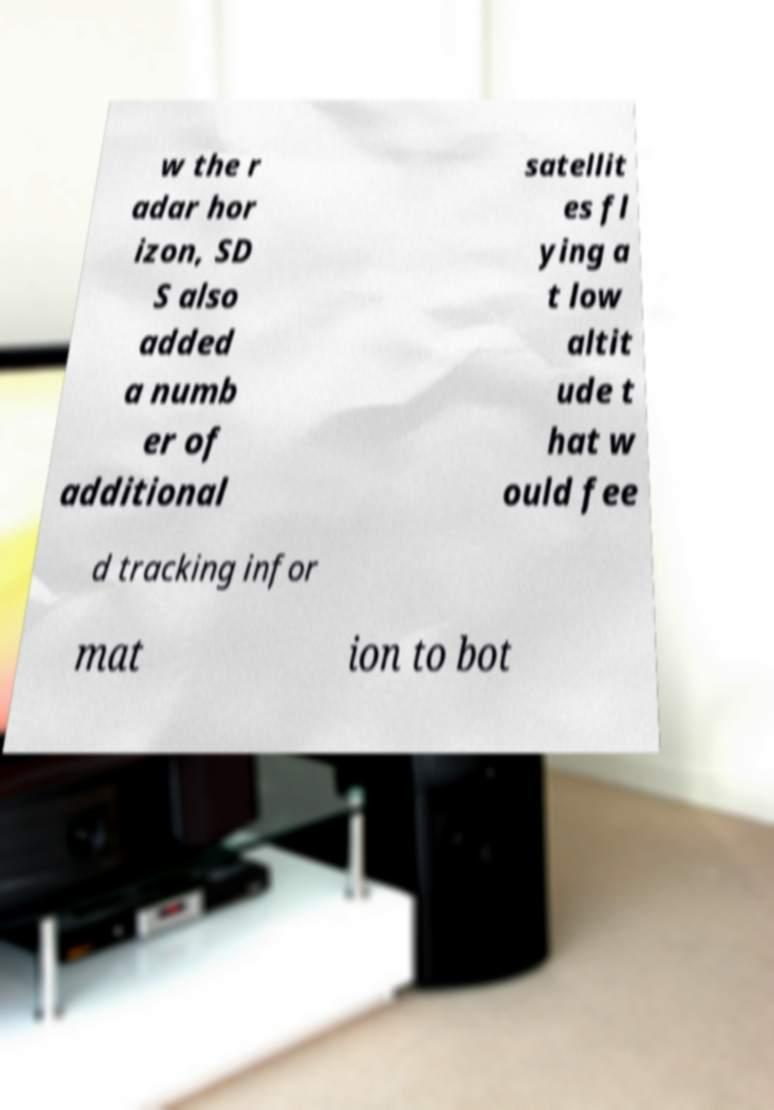Can you read and provide the text displayed in the image?This photo seems to have some interesting text. Can you extract and type it out for me? w the r adar hor izon, SD S also added a numb er of additional satellit es fl ying a t low altit ude t hat w ould fee d tracking infor mat ion to bot 